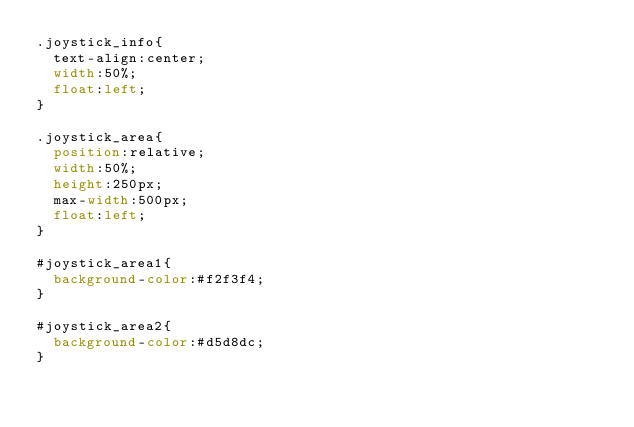Convert code to text. <code><loc_0><loc_0><loc_500><loc_500><_CSS_>.joystick_info{
	text-align:center;
	width:50%;
	float:left;
}

.joystick_area{
	position:relative;
	width:50%;
	height:250px;
	max-width:500px;
	float:left;
}

#joystick_area1{
	background-color:#f2f3f4;
}

#joystick_area2{
	background-color:#d5d8dc;
}
</code> 